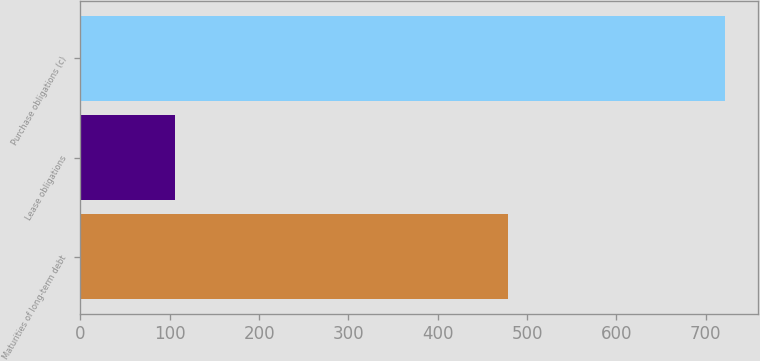Convert chart. <chart><loc_0><loc_0><loc_500><loc_500><bar_chart><fcel>Maturities of long-term debt<fcel>Lease obligations<fcel>Purchase obligations (c)<nl><fcel>479<fcel>106<fcel>722<nl></chart> 